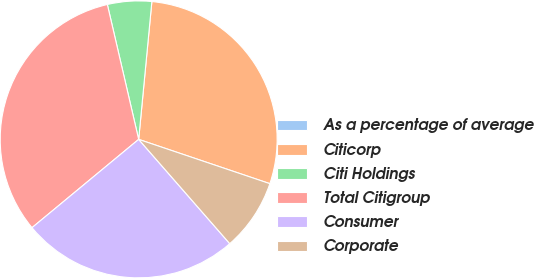Convert chart. <chart><loc_0><loc_0><loc_500><loc_500><pie_chart><fcel>As a percentage of average<fcel>Citicorp<fcel>Citi Holdings<fcel>Total Citigroup<fcel>Consumer<fcel>Corporate<nl><fcel>0.0%<fcel>28.66%<fcel>5.15%<fcel>32.37%<fcel>25.42%<fcel>8.39%<nl></chart> 